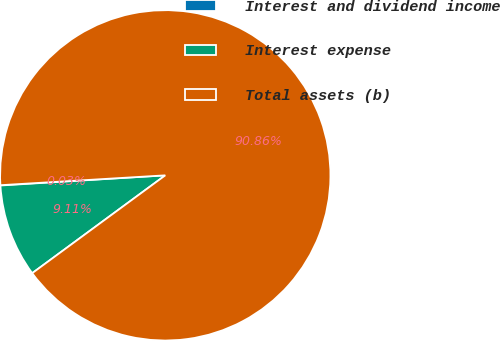Convert chart to OTSL. <chart><loc_0><loc_0><loc_500><loc_500><pie_chart><fcel>Interest and dividend income<fcel>Interest expense<fcel>Total assets (b)<nl><fcel>0.03%<fcel>9.11%<fcel>90.86%<nl></chart> 